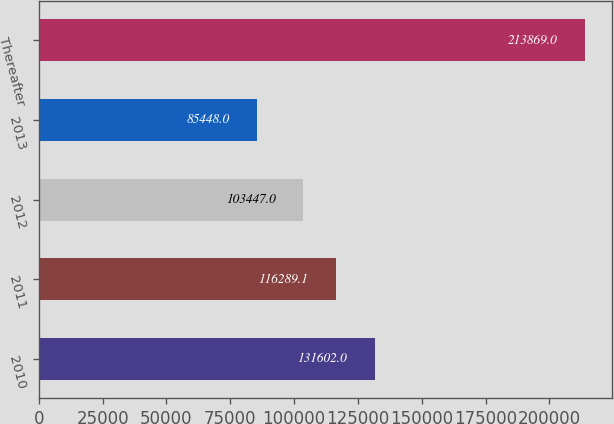Convert chart to OTSL. <chart><loc_0><loc_0><loc_500><loc_500><bar_chart><fcel>2010<fcel>2011<fcel>2012<fcel>2013<fcel>Thereafter<nl><fcel>131602<fcel>116289<fcel>103447<fcel>85448<fcel>213869<nl></chart> 